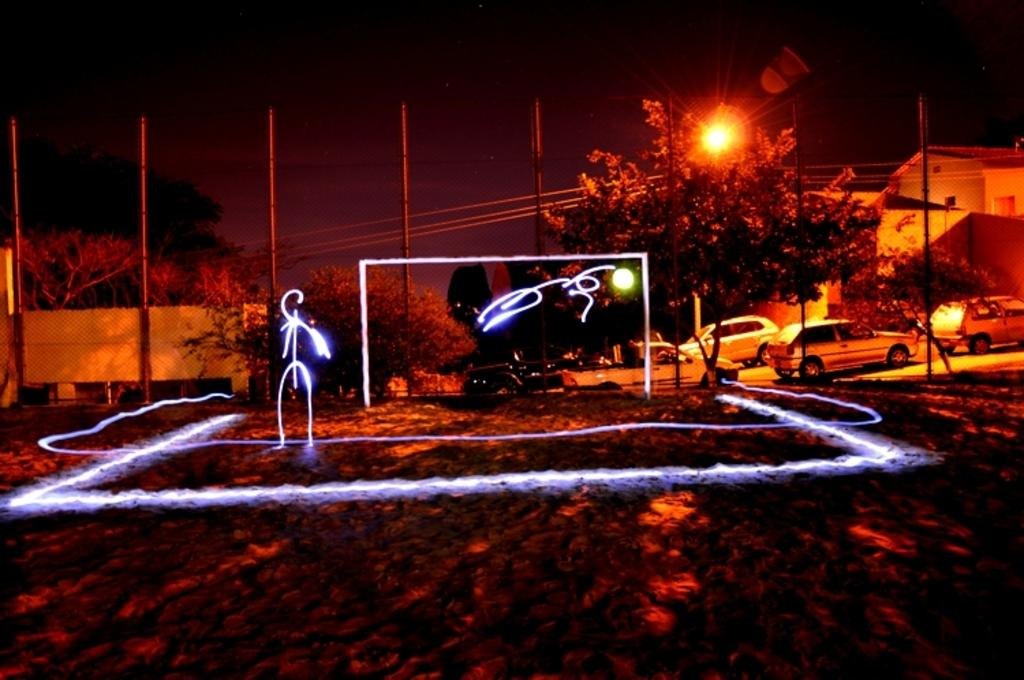What type of lights can be seen in the image? There are laser lights in the image. What natural elements are present in the image? There are trees in the image. What structures can be seen in the image? There are poles, at least one building, walls, and mesh in the image. What else is visible in the image? There are vehicles and lights in the image. Can you tell me how many ants are crawling on the mesh in the image? There are no ants present in the image; it features laser lights, trees, poles, a building, vehicles, and lights, but no ants. What type of haircut is the building in the image sporting? The building in the image does not have a haircut, as it is a structure and not a living being. 